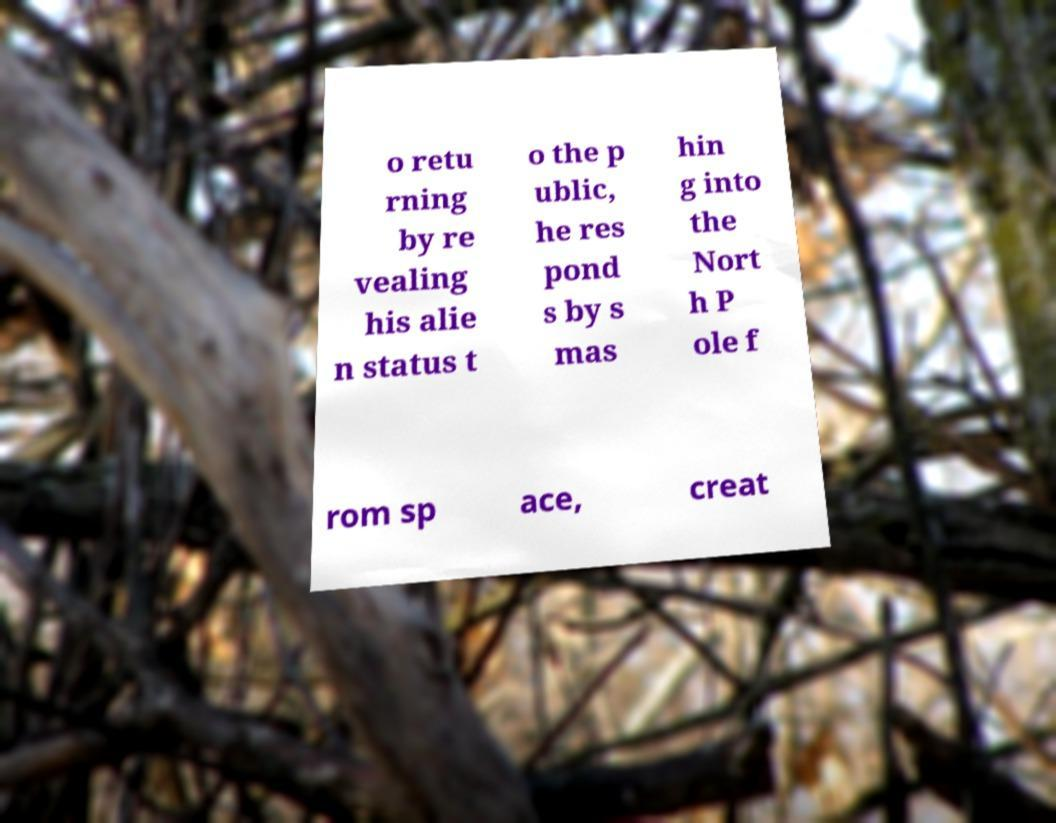Could you extract and type out the text from this image? o retu rning by re vealing his alie n status t o the p ublic, he res pond s by s mas hin g into the Nort h P ole f rom sp ace, creat 